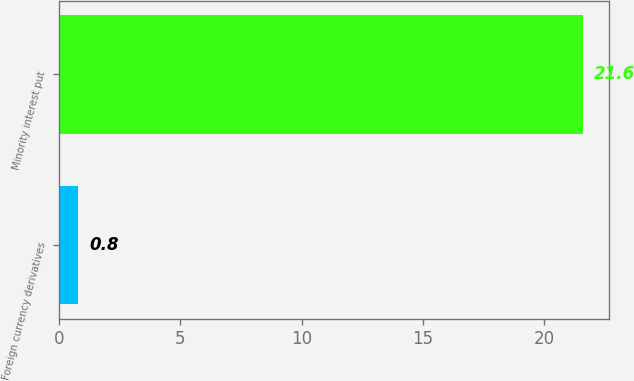Convert chart. <chart><loc_0><loc_0><loc_500><loc_500><bar_chart><fcel>Foreign currency derivatives<fcel>Minority interest put<nl><fcel>0.8<fcel>21.6<nl></chart> 